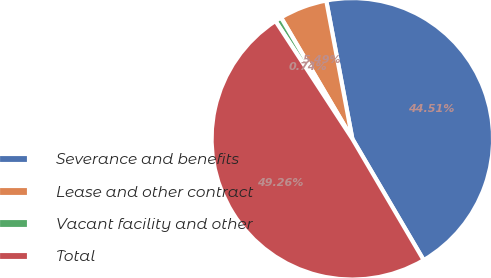Convert chart. <chart><loc_0><loc_0><loc_500><loc_500><pie_chart><fcel>Severance and benefits<fcel>Lease and other contract<fcel>Vacant facility and other<fcel>Total<nl><fcel>44.51%<fcel>5.49%<fcel>0.74%<fcel>49.26%<nl></chart> 